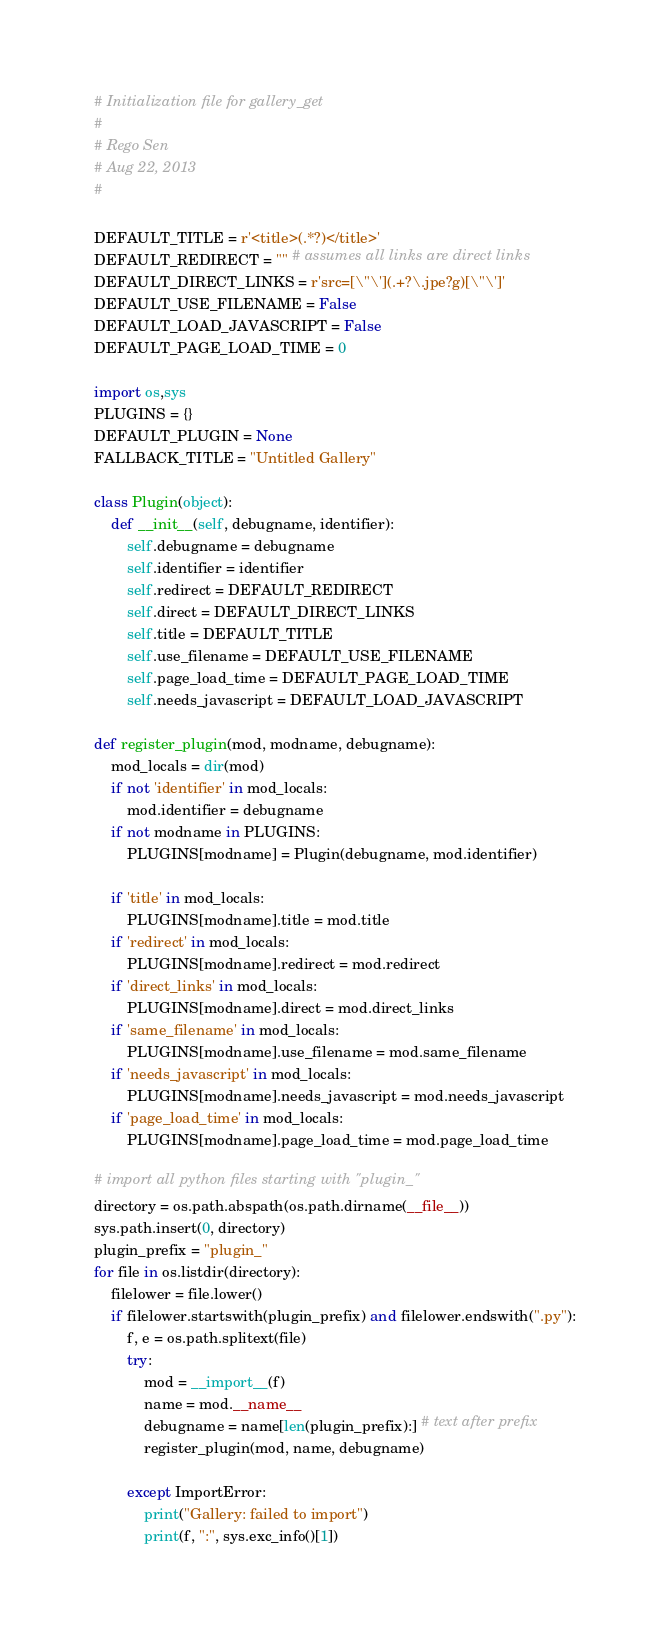<code> <loc_0><loc_0><loc_500><loc_500><_Python_># Initialization file for gallery_get
#
# Rego Sen
# Aug 22, 2013
#

DEFAULT_TITLE = r'<title>(.*?)</title>'
DEFAULT_REDIRECT = "" # assumes all links are direct links
DEFAULT_DIRECT_LINKS = r'src=[\"\'](.+?\.jpe?g)[\"\']'
DEFAULT_USE_FILENAME = False
DEFAULT_LOAD_JAVASCRIPT = False
DEFAULT_PAGE_LOAD_TIME = 0

import os,sys
PLUGINS = {}
DEFAULT_PLUGIN = None
FALLBACK_TITLE = "Untitled Gallery"

class Plugin(object):
    def __init__(self, debugname, identifier):
        self.debugname = debugname
        self.identifier = identifier
        self.redirect = DEFAULT_REDIRECT
        self.direct = DEFAULT_DIRECT_LINKS
        self.title = DEFAULT_TITLE
        self.use_filename = DEFAULT_USE_FILENAME
        self.page_load_time = DEFAULT_PAGE_LOAD_TIME
        self.needs_javascript = DEFAULT_LOAD_JAVASCRIPT

def register_plugin(mod, modname, debugname):
    mod_locals = dir(mod)
    if not 'identifier' in mod_locals:
        mod.identifier = debugname
    if not modname in PLUGINS:
        PLUGINS[modname] = Plugin(debugname, mod.identifier)

    if 'title' in mod_locals:
        PLUGINS[modname].title = mod.title 
    if 'redirect' in mod_locals:
        PLUGINS[modname].redirect = mod.redirect 
    if 'direct_links' in mod_locals:
        PLUGINS[modname].direct = mod.direct_links 
    if 'same_filename' in mod_locals:
        PLUGINS[modname].use_filename = mod.same_filename 
    if 'needs_javascript' in mod_locals:
        PLUGINS[modname].needs_javascript = mod.needs_javascript 
    if 'page_load_time' in mod_locals:
        PLUGINS[modname].page_load_time = mod.page_load_time 

# import all python files starting with "plugin_"
directory = os.path.abspath(os.path.dirname(__file__))
sys.path.insert(0, directory)
plugin_prefix = "plugin_"
for file in os.listdir(directory):
    filelower = file.lower()
    if filelower.startswith(plugin_prefix) and filelower.endswith(".py"):
        f, e = os.path.splitext(file)
        try:
            mod = __import__(f)
            name = mod.__name__
            debugname = name[len(plugin_prefix):] # text after prefix
            register_plugin(mod, name, debugname)
            
        except ImportError:
            print("Gallery: failed to import")
            print(f, ":", sys.exc_info()[1])
</code> 